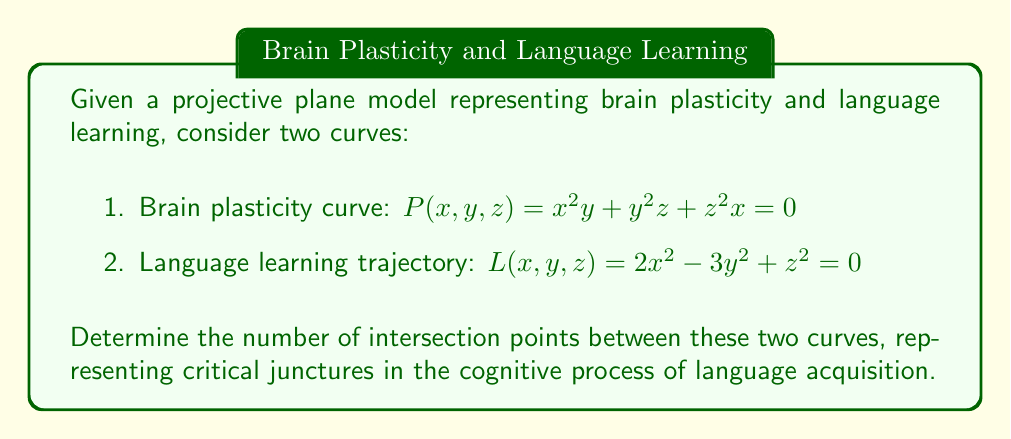Teach me how to tackle this problem. To find the number of intersection points between the two curves on the projective plane, we'll follow these steps:

1) First, we need to find the degree of each curve:
   - $P(x,y,z) = x^2y + y^2z + z^2x = 0$ is of degree 3
   - $L(x,y,z) = 2x^2 - 3y^2 + z^2 = 0$ is of degree 2

2) In projective geometry, Bézout's theorem states that two curves of degrees $m$ and $n$ intersect in exactly $mn$ points, counting multiplicities and complex points.

3) In this case:
   - Degree of $P(x,y,z) = 3$
   - Degree of $L(x,y,z) = 2$

4) Applying Bézout's theorem:
   Number of intersection points = $3 \times 2 = 6$

5) These 6 points represent the critical junctures where the brain plasticity curve intersects with the language learning trajectory, potentially indicating key moments in the cognitive process of language acquisition.

Note: Some of these points may be complex or occur with multiplicity greater than 1, but Bézout's theorem counts them all, giving us the total number of intersection points in the projective plane.
Answer: 6 intersection points 